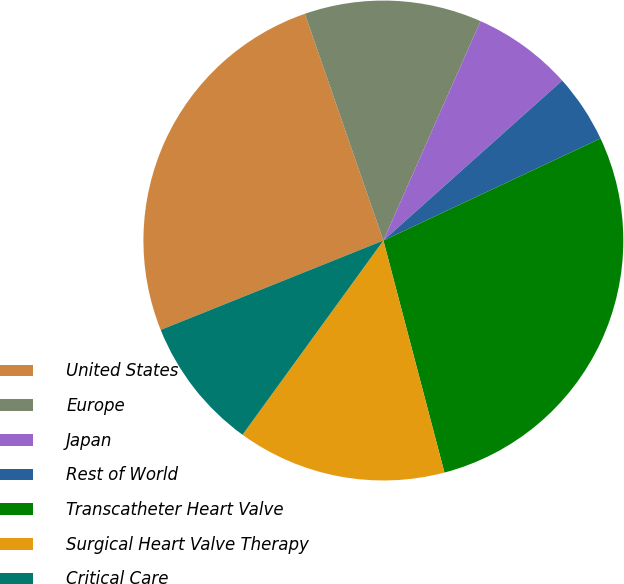<chart> <loc_0><loc_0><loc_500><loc_500><pie_chart><fcel>United States<fcel>Europe<fcel>Japan<fcel>Rest of World<fcel>Transcatheter Heart Valve<fcel>Surgical Heart Valve Therapy<fcel>Critical Care<nl><fcel>25.77%<fcel>11.94%<fcel>6.75%<fcel>4.62%<fcel>27.9%<fcel>14.08%<fcel>8.94%<nl></chart> 